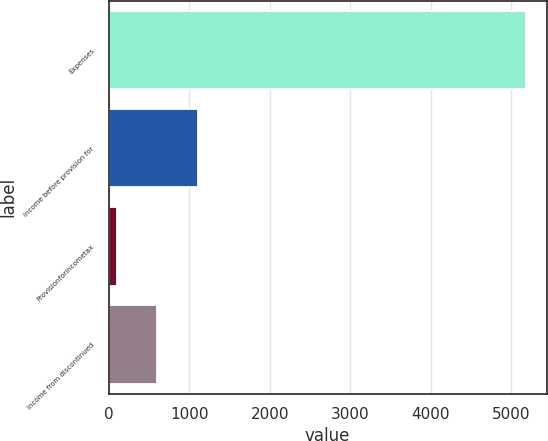Convert chart. <chart><loc_0><loc_0><loc_500><loc_500><bar_chart><fcel>Expenses<fcel>Income before provision for<fcel>Provisionforincometax<fcel>Income from discontinued<nl><fcel>5179<fcel>1115<fcel>99<fcel>607<nl></chart> 